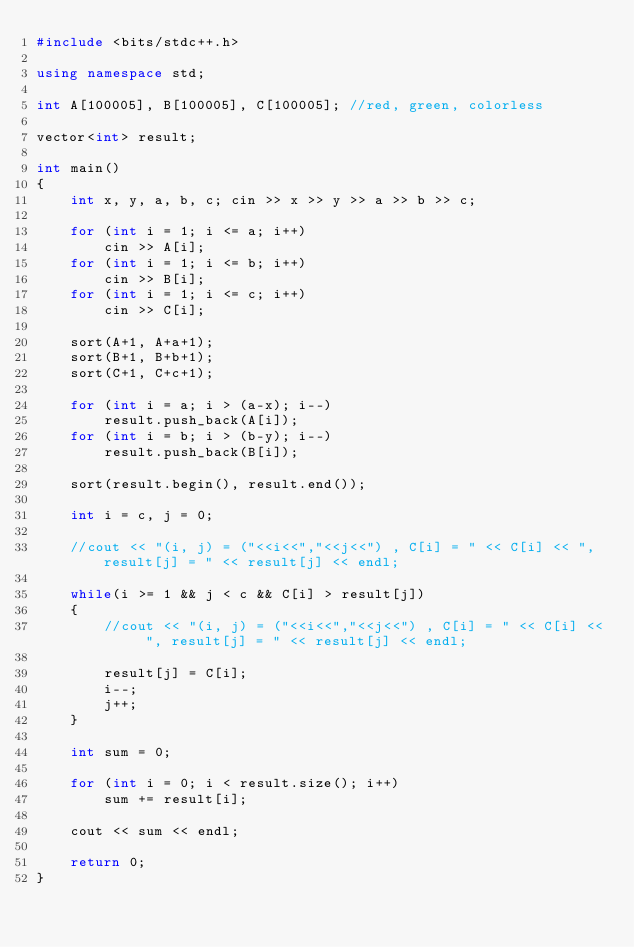Convert code to text. <code><loc_0><loc_0><loc_500><loc_500><_C++_>#include <bits/stdc++.h>

using namespace std;

int A[100005], B[100005], C[100005]; //red, green, colorless

vector<int> result;

int main()
{
    int x, y, a, b, c; cin >> x >> y >> a >> b >> c;

    for (int i = 1; i <= a; i++)
        cin >> A[i];
    for (int i = 1; i <= b; i++)
        cin >> B[i];
    for (int i = 1; i <= c; i++)
        cin >> C[i];

    sort(A+1, A+a+1);
    sort(B+1, B+b+1);
    sort(C+1, C+c+1);

    for (int i = a; i > (a-x); i--)
        result.push_back(A[i]);
    for (int i = b; i > (b-y); i--)
        result.push_back(B[i]);

    sort(result.begin(), result.end());

    int i = c, j = 0;

    //cout << "(i, j) = ("<<i<<","<<j<<") , C[i] = " << C[i] << ", result[j] = " << result[j] << endl;

    while(i >= 1 && j < c && C[i] > result[j])
    {
        //cout << "(i, j) = ("<<i<<","<<j<<") , C[i] = " << C[i] << ", result[j] = " << result[j] << endl;

        result[j] = C[i];
        i--;
        j++;
    }

    int sum = 0;

    for (int i = 0; i < result.size(); i++)
        sum += result[i];

    cout << sum << endl;

    return 0;
}
</code> 